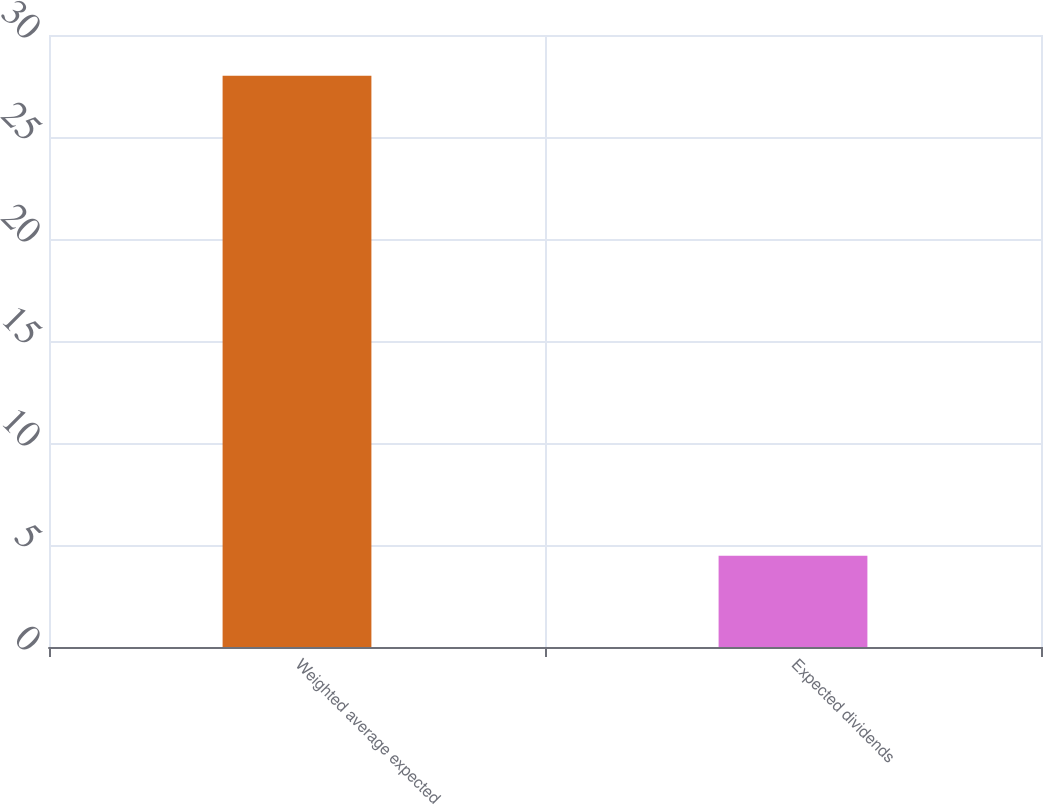Convert chart to OTSL. <chart><loc_0><loc_0><loc_500><loc_500><bar_chart><fcel>Weighted average expected<fcel>Expected dividends<nl><fcel>28<fcel>4.47<nl></chart> 